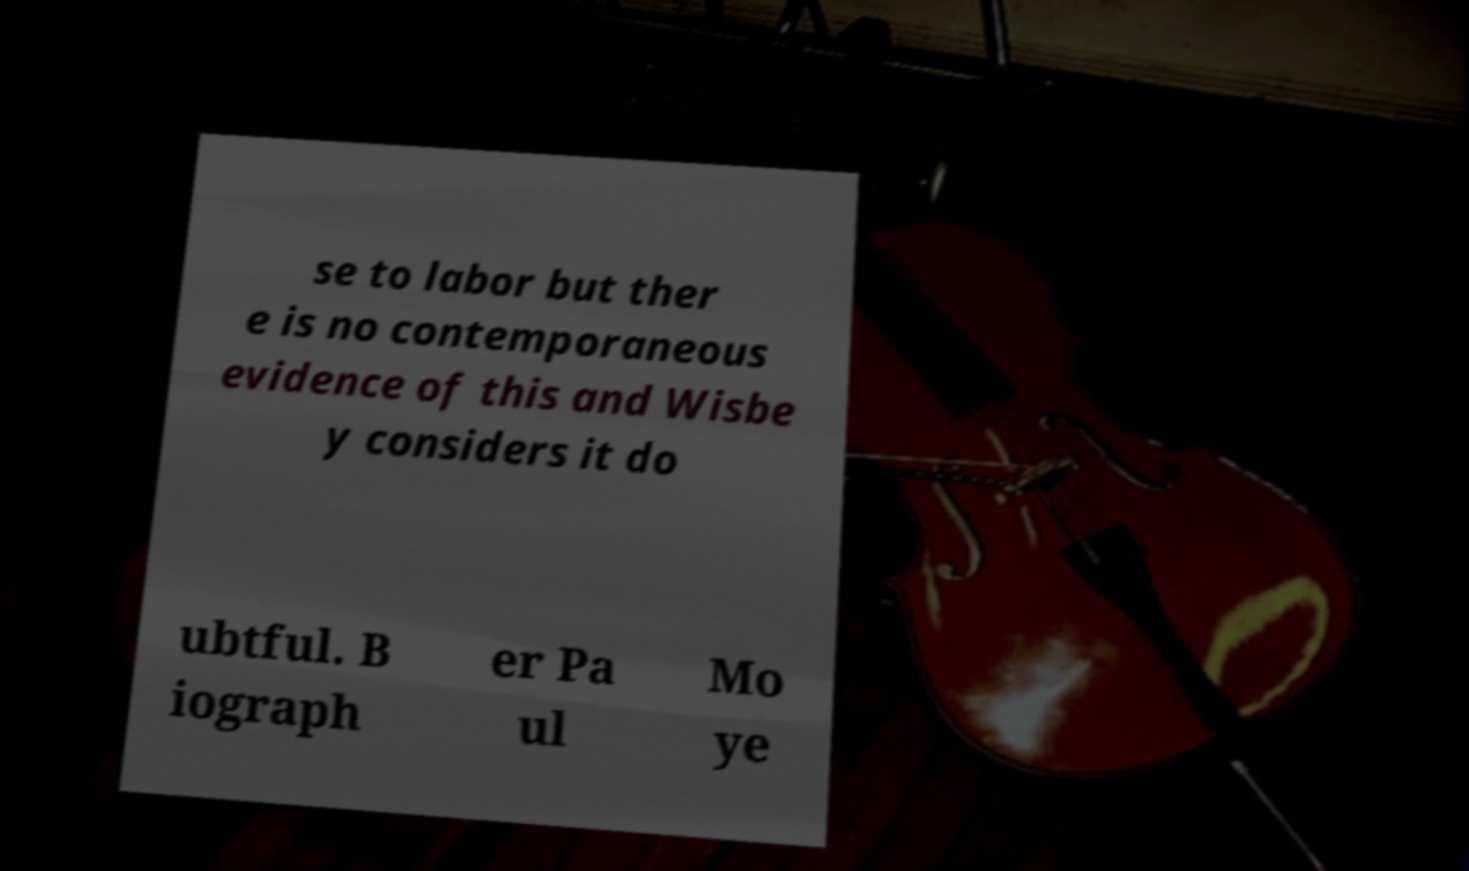Could you extract and type out the text from this image? se to labor but ther e is no contemporaneous evidence of this and Wisbe y considers it do ubtful. B iograph er Pa ul Mo ye 